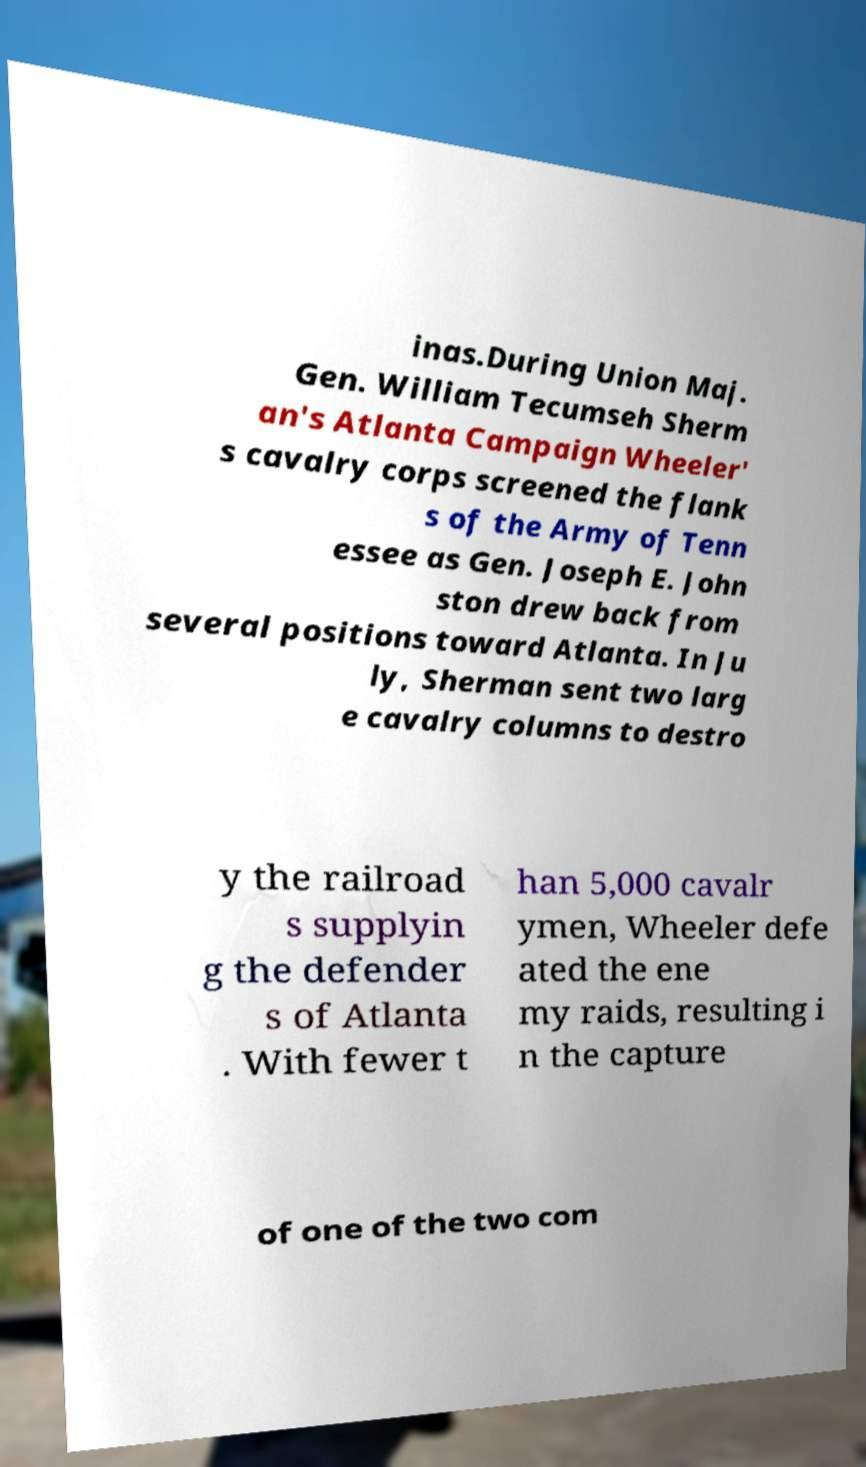Can you accurately transcribe the text from the provided image for me? inas.During Union Maj. Gen. William Tecumseh Sherm an's Atlanta Campaign Wheeler' s cavalry corps screened the flank s of the Army of Tenn essee as Gen. Joseph E. John ston drew back from several positions toward Atlanta. In Ju ly, Sherman sent two larg e cavalry columns to destro y the railroad s supplyin g the defender s of Atlanta . With fewer t han 5,000 cavalr ymen, Wheeler defe ated the ene my raids, resulting i n the capture of one of the two com 